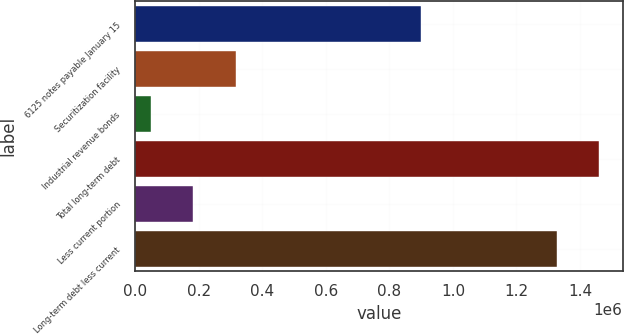Convert chart to OTSL. <chart><loc_0><loc_0><loc_500><loc_500><bar_chart><fcel>6125 notes payable January 15<fcel>Securitization facility<fcel>Industrial revenue bonds<fcel>Total long-term debt<fcel>Less current portion<fcel>Long-term debt less current<nl><fcel>900000<fcel>315842<fcel>49067<fcel>1.46112e+06<fcel>182454<fcel>1.32773e+06<nl></chart> 